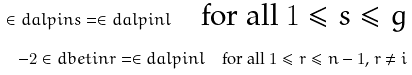Convert formula to latex. <formula><loc_0><loc_0><loc_500><loc_500>\in d a l p i n s = \in d a l p i n l \quad \text {for all $1\leqslant s\leqslant g$} \\ - 2 \in d b e t i n r = \in d a l p i n l \quad \text {for all $1\leqslant r\leqslant n-1$, $r\neq i$}</formula> 